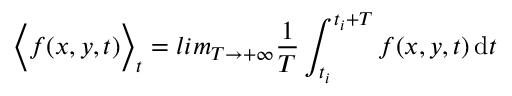<formula> <loc_0><loc_0><loc_500><loc_500>\left \langle f ( x , y , t ) \right \rangle _ { t } = l i m _ { T \rightarrow + \infty } \frac { 1 } { T } \int _ { t _ { i } } ^ { t _ { i } + T } f ( x , y , t ) \, d t</formula> 